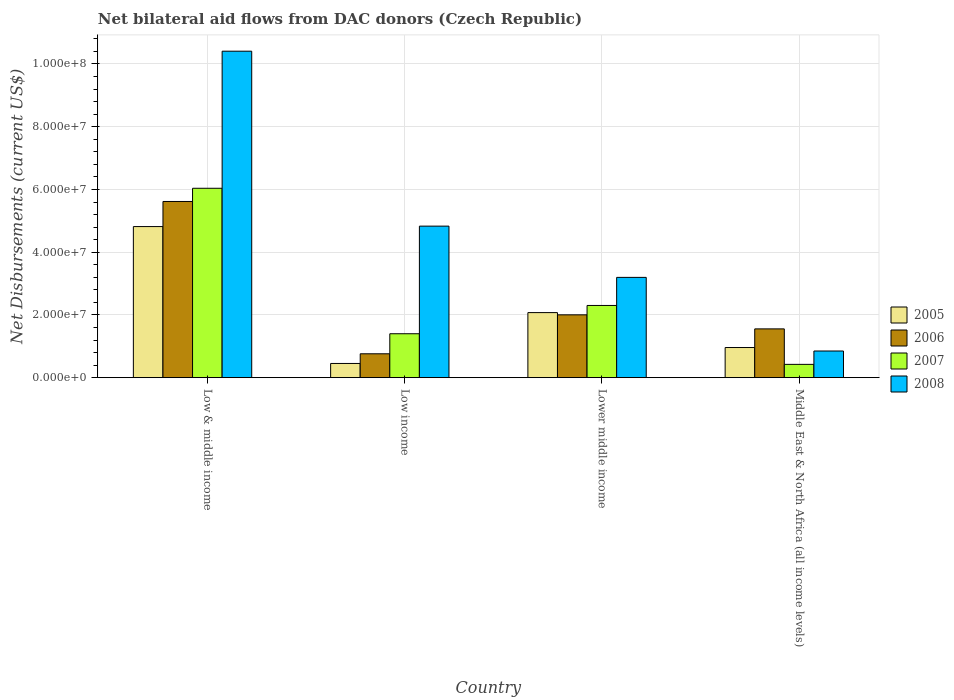How many groups of bars are there?
Offer a terse response. 4. Are the number of bars per tick equal to the number of legend labels?
Keep it short and to the point. Yes. Are the number of bars on each tick of the X-axis equal?
Keep it short and to the point. Yes. How many bars are there on the 1st tick from the left?
Make the answer very short. 4. What is the net bilateral aid flows in 2008 in Middle East & North Africa (all income levels)?
Offer a terse response. 8.50e+06. Across all countries, what is the maximum net bilateral aid flows in 2007?
Provide a short and direct response. 6.04e+07. Across all countries, what is the minimum net bilateral aid flows in 2008?
Keep it short and to the point. 8.50e+06. What is the total net bilateral aid flows in 2008 in the graph?
Provide a short and direct response. 1.93e+08. What is the difference between the net bilateral aid flows in 2008 in Low & middle income and that in Lower middle income?
Your answer should be very brief. 7.21e+07. What is the difference between the net bilateral aid flows in 2008 in Low income and the net bilateral aid flows in 2005 in Middle East & North Africa (all income levels)?
Make the answer very short. 3.87e+07. What is the average net bilateral aid flows in 2007 per country?
Ensure brevity in your answer.  2.54e+07. What is the difference between the net bilateral aid flows of/in 2008 and net bilateral aid flows of/in 2006 in Low income?
Your answer should be compact. 4.07e+07. In how many countries, is the net bilateral aid flows in 2007 greater than 56000000 US$?
Your response must be concise. 1. What is the ratio of the net bilateral aid flows in 2007 in Low income to that in Lower middle income?
Your response must be concise. 0.61. Is the difference between the net bilateral aid flows in 2008 in Lower middle income and Middle East & North Africa (all income levels) greater than the difference between the net bilateral aid flows in 2006 in Lower middle income and Middle East & North Africa (all income levels)?
Ensure brevity in your answer.  Yes. What is the difference between the highest and the second highest net bilateral aid flows in 2007?
Your answer should be very brief. 3.74e+07. What is the difference between the highest and the lowest net bilateral aid flows in 2006?
Your answer should be compact. 4.86e+07. In how many countries, is the net bilateral aid flows in 2005 greater than the average net bilateral aid flows in 2005 taken over all countries?
Your response must be concise. 1. Is the sum of the net bilateral aid flows in 2007 in Low & middle income and Low income greater than the maximum net bilateral aid flows in 2006 across all countries?
Offer a terse response. Yes. What does the 4th bar from the right in Middle East & North Africa (all income levels) represents?
Offer a terse response. 2005. Is it the case that in every country, the sum of the net bilateral aid flows in 2005 and net bilateral aid flows in 2006 is greater than the net bilateral aid flows in 2008?
Make the answer very short. No. How many bars are there?
Make the answer very short. 16. Does the graph contain any zero values?
Make the answer very short. No. Does the graph contain grids?
Your answer should be very brief. Yes. Where does the legend appear in the graph?
Keep it short and to the point. Center right. What is the title of the graph?
Give a very brief answer. Net bilateral aid flows from DAC donors (Czech Republic). What is the label or title of the X-axis?
Give a very brief answer. Country. What is the label or title of the Y-axis?
Keep it short and to the point. Net Disbursements (current US$). What is the Net Disbursements (current US$) in 2005 in Low & middle income?
Make the answer very short. 4.82e+07. What is the Net Disbursements (current US$) in 2006 in Low & middle income?
Keep it short and to the point. 5.62e+07. What is the Net Disbursements (current US$) in 2007 in Low & middle income?
Ensure brevity in your answer.  6.04e+07. What is the Net Disbursements (current US$) in 2008 in Low & middle income?
Give a very brief answer. 1.04e+08. What is the Net Disbursements (current US$) in 2005 in Low income?
Your response must be concise. 4.53e+06. What is the Net Disbursements (current US$) of 2006 in Low income?
Your response must be concise. 7.61e+06. What is the Net Disbursements (current US$) in 2007 in Low income?
Offer a very short reply. 1.40e+07. What is the Net Disbursements (current US$) in 2008 in Low income?
Provide a short and direct response. 4.83e+07. What is the Net Disbursements (current US$) in 2005 in Lower middle income?
Offer a terse response. 2.07e+07. What is the Net Disbursements (current US$) in 2006 in Lower middle income?
Offer a terse response. 2.00e+07. What is the Net Disbursements (current US$) of 2007 in Lower middle income?
Provide a short and direct response. 2.30e+07. What is the Net Disbursements (current US$) in 2008 in Lower middle income?
Your response must be concise. 3.20e+07. What is the Net Disbursements (current US$) in 2005 in Middle East & North Africa (all income levels)?
Offer a terse response. 9.61e+06. What is the Net Disbursements (current US$) of 2006 in Middle East & North Africa (all income levels)?
Keep it short and to the point. 1.56e+07. What is the Net Disbursements (current US$) of 2007 in Middle East & North Africa (all income levels)?
Make the answer very short. 4.24e+06. What is the Net Disbursements (current US$) in 2008 in Middle East & North Africa (all income levels)?
Your answer should be compact. 8.50e+06. Across all countries, what is the maximum Net Disbursements (current US$) in 2005?
Offer a terse response. 4.82e+07. Across all countries, what is the maximum Net Disbursements (current US$) of 2006?
Offer a terse response. 5.62e+07. Across all countries, what is the maximum Net Disbursements (current US$) of 2007?
Keep it short and to the point. 6.04e+07. Across all countries, what is the maximum Net Disbursements (current US$) of 2008?
Ensure brevity in your answer.  1.04e+08. Across all countries, what is the minimum Net Disbursements (current US$) of 2005?
Offer a terse response. 4.53e+06. Across all countries, what is the minimum Net Disbursements (current US$) of 2006?
Offer a very short reply. 7.61e+06. Across all countries, what is the minimum Net Disbursements (current US$) in 2007?
Ensure brevity in your answer.  4.24e+06. Across all countries, what is the minimum Net Disbursements (current US$) of 2008?
Your answer should be compact. 8.50e+06. What is the total Net Disbursements (current US$) in 2005 in the graph?
Offer a very short reply. 8.30e+07. What is the total Net Disbursements (current US$) in 2006 in the graph?
Provide a succinct answer. 9.94e+07. What is the total Net Disbursements (current US$) of 2007 in the graph?
Your response must be concise. 1.02e+08. What is the total Net Disbursements (current US$) in 2008 in the graph?
Offer a very short reply. 1.93e+08. What is the difference between the Net Disbursements (current US$) in 2005 in Low & middle income and that in Low income?
Keep it short and to the point. 4.36e+07. What is the difference between the Net Disbursements (current US$) in 2006 in Low & middle income and that in Low income?
Your answer should be very brief. 4.86e+07. What is the difference between the Net Disbursements (current US$) of 2007 in Low & middle income and that in Low income?
Your answer should be very brief. 4.64e+07. What is the difference between the Net Disbursements (current US$) of 2008 in Low & middle income and that in Low income?
Offer a terse response. 5.58e+07. What is the difference between the Net Disbursements (current US$) of 2005 in Low & middle income and that in Lower middle income?
Make the answer very short. 2.74e+07. What is the difference between the Net Disbursements (current US$) of 2006 in Low & middle income and that in Lower middle income?
Your response must be concise. 3.61e+07. What is the difference between the Net Disbursements (current US$) in 2007 in Low & middle income and that in Lower middle income?
Provide a short and direct response. 3.74e+07. What is the difference between the Net Disbursements (current US$) in 2008 in Low & middle income and that in Lower middle income?
Offer a very short reply. 7.21e+07. What is the difference between the Net Disbursements (current US$) of 2005 in Low & middle income and that in Middle East & North Africa (all income levels)?
Your answer should be compact. 3.86e+07. What is the difference between the Net Disbursements (current US$) in 2006 in Low & middle income and that in Middle East & North Africa (all income levels)?
Offer a terse response. 4.06e+07. What is the difference between the Net Disbursements (current US$) of 2007 in Low & middle income and that in Middle East & North Africa (all income levels)?
Provide a succinct answer. 5.61e+07. What is the difference between the Net Disbursements (current US$) in 2008 in Low & middle income and that in Middle East & North Africa (all income levels)?
Provide a short and direct response. 9.56e+07. What is the difference between the Net Disbursements (current US$) of 2005 in Low income and that in Lower middle income?
Your answer should be very brief. -1.62e+07. What is the difference between the Net Disbursements (current US$) of 2006 in Low income and that in Lower middle income?
Offer a terse response. -1.24e+07. What is the difference between the Net Disbursements (current US$) in 2007 in Low income and that in Lower middle income?
Keep it short and to the point. -9.02e+06. What is the difference between the Net Disbursements (current US$) in 2008 in Low income and that in Lower middle income?
Your answer should be very brief. 1.63e+07. What is the difference between the Net Disbursements (current US$) in 2005 in Low income and that in Middle East & North Africa (all income levels)?
Make the answer very short. -5.08e+06. What is the difference between the Net Disbursements (current US$) of 2006 in Low income and that in Middle East & North Africa (all income levels)?
Your answer should be very brief. -7.94e+06. What is the difference between the Net Disbursements (current US$) of 2007 in Low income and that in Middle East & North Africa (all income levels)?
Your answer should be very brief. 9.76e+06. What is the difference between the Net Disbursements (current US$) in 2008 in Low income and that in Middle East & North Africa (all income levels)?
Offer a terse response. 3.98e+07. What is the difference between the Net Disbursements (current US$) of 2005 in Lower middle income and that in Middle East & North Africa (all income levels)?
Make the answer very short. 1.11e+07. What is the difference between the Net Disbursements (current US$) in 2006 in Lower middle income and that in Middle East & North Africa (all income levels)?
Your answer should be very brief. 4.48e+06. What is the difference between the Net Disbursements (current US$) of 2007 in Lower middle income and that in Middle East & North Africa (all income levels)?
Ensure brevity in your answer.  1.88e+07. What is the difference between the Net Disbursements (current US$) of 2008 in Lower middle income and that in Middle East & North Africa (all income levels)?
Keep it short and to the point. 2.35e+07. What is the difference between the Net Disbursements (current US$) in 2005 in Low & middle income and the Net Disbursements (current US$) in 2006 in Low income?
Make the answer very short. 4.06e+07. What is the difference between the Net Disbursements (current US$) in 2005 in Low & middle income and the Net Disbursements (current US$) in 2007 in Low income?
Make the answer very short. 3.42e+07. What is the difference between the Net Disbursements (current US$) in 2005 in Low & middle income and the Net Disbursements (current US$) in 2008 in Low income?
Your answer should be very brief. -1.40e+05. What is the difference between the Net Disbursements (current US$) in 2006 in Low & middle income and the Net Disbursements (current US$) in 2007 in Low income?
Provide a short and direct response. 4.22e+07. What is the difference between the Net Disbursements (current US$) in 2006 in Low & middle income and the Net Disbursements (current US$) in 2008 in Low income?
Provide a succinct answer. 7.86e+06. What is the difference between the Net Disbursements (current US$) in 2007 in Low & middle income and the Net Disbursements (current US$) in 2008 in Low income?
Make the answer very short. 1.21e+07. What is the difference between the Net Disbursements (current US$) in 2005 in Low & middle income and the Net Disbursements (current US$) in 2006 in Lower middle income?
Make the answer very short. 2.81e+07. What is the difference between the Net Disbursements (current US$) in 2005 in Low & middle income and the Net Disbursements (current US$) in 2007 in Lower middle income?
Ensure brevity in your answer.  2.52e+07. What is the difference between the Net Disbursements (current US$) in 2005 in Low & middle income and the Net Disbursements (current US$) in 2008 in Lower middle income?
Give a very brief answer. 1.62e+07. What is the difference between the Net Disbursements (current US$) in 2006 in Low & middle income and the Net Disbursements (current US$) in 2007 in Lower middle income?
Ensure brevity in your answer.  3.32e+07. What is the difference between the Net Disbursements (current US$) in 2006 in Low & middle income and the Net Disbursements (current US$) in 2008 in Lower middle income?
Keep it short and to the point. 2.42e+07. What is the difference between the Net Disbursements (current US$) of 2007 in Low & middle income and the Net Disbursements (current US$) of 2008 in Lower middle income?
Ensure brevity in your answer.  2.84e+07. What is the difference between the Net Disbursements (current US$) in 2005 in Low & middle income and the Net Disbursements (current US$) in 2006 in Middle East & North Africa (all income levels)?
Make the answer very short. 3.26e+07. What is the difference between the Net Disbursements (current US$) of 2005 in Low & middle income and the Net Disbursements (current US$) of 2007 in Middle East & North Africa (all income levels)?
Provide a succinct answer. 4.39e+07. What is the difference between the Net Disbursements (current US$) of 2005 in Low & middle income and the Net Disbursements (current US$) of 2008 in Middle East & North Africa (all income levels)?
Offer a terse response. 3.97e+07. What is the difference between the Net Disbursements (current US$) of 2006 in Low & middle income and the Net Disbursements (current US$) of 2007 in Middle East & North Africa (all income levels)?
Provide a succinct answer. 5.19e+07. What is the difference between the Net Disbursements (current US$) in 2006 in Low & middle income and the Net Disbursements (current US$) in 2008 in Middle East & North Africa (all income levels)?
Offer a terse response. 4.77e+07. What is the difference between the Net Disbursements (current US$) of 2007 in Low & middle income and the Net Disbursements (current US$) of 2008 in Middle East & North Africa (all income levels)?
Provide a short and direct response. 5.19e+07. What is the difference between the Net Disbursements (current US$) in 2005 in Low income and the Net Disbursements (current US$) in 2006 in Lower middle income?
Offer a terse response. -1.55e+07. What is the difference between the Net Disbursements (current US$) in 2005 in Low income and the Net Disbursements (current US$) in 2007 in Lower middle income?
Provide a succinct answer. -1.85e+07. What is the difference between the Net Disbursements (current US$) in 2005 in Low income and the Net Disbursements (current US$) in 2008 in Lower middle income?
Give a very brief answer. -2.74e+07. What is the difference between the Net Disbursements (current US$) of 2006 in Low income and the Net Disbursements (current US$) of 2007 in Lower middle income?
Offer a very short reply. -1.54e+07. What is the difference between the Net Disbursements (current US$) of 2006 in Low income and the Net Disbursements (current US$) of 2008 in Lower middle income?
Ensure brevity in your answer.  -2.44e+07. What is the difference between the Net Disbursements (current US$) in 2007 in Low income and the Net Disbursements (current US$) in 2008 in Lower middle income?
Your answer should be very brief. -1.80e+07. What is the difference between the Net Disbursements (current US$) in 2005 in Low income and the Net Disbursements (current US$) in 2006 in Middle East & North Africa (all income levels)?
Provide a succinct answer. -1.10e+07. What is the difference between the Net Disbursements (current US$) in 2005 in Low income and the Net Disbursements (current US$) in 2007 in Middle East & North Africa (all income levels)?
Your response must be concise. 2.90e+05. What is the difference between the Net Disbursements (current US$) of 2005 in Low income and the Net Disbursements (current US$) of 2008 in Middle East & North Africa (all income levels)?
Offer a very short reply. -3.97e+06. What is the difference between the Net Disbursements (current US$) in 2006 in Low income and the Net Disbursements (current US$) in 2007 in Middle East & North Africa (all income levels)?
Provide a short and direct response. 3.37e+06. What is the difference between the Net Disbursements (current US$) of 2006 in Low income and the Net Disbursements (current US$) of 2008 in Middle East & North Africa (all income levels)?
Your answer should be compact. -8.90e+05. What is the difference between the Net Disbursements (current US$) in 2007 in Low income and the Net Disbursements (current US$) in 2008 in Middle East & North Africa (all income levels)?
Offer a terse response. 5.50e+06. What is the difference between the Net Disbursements (current US$) in 2005 in Lower middle income and the Net Disbursements (current US$) in 2006 in Middle East & North Africa (all income levels)?
Your answer should be compact. 5.19e+06. What is the difference between the Net Disbursements (current US$) in 2005 in Lower middle income and the Net Disbursements (current US$) in 2007 in Middle East & North Africa (all income levels)?
Your answer should be very brief. 1.65e+07. What is the difference between the Net Disbursements (current US$) in 2005 in Lower middle income and the Net Disbursements (current US$) in 2008 in Middle East & North Africa (all income levels)?
Offer a very short reply. 1.22e+07. What is the difference between the Net Disbursements (current US$) of 2006 in Lower middle income and the Net Disbursements (current US$) of 2007 in Middle East & North Africa (all income levels)?
Offer a terse response. 1.58e+07. What is the difference between the Net Disbursements (current US$) in 2006 in Lower middle income and the Net Disbursements (current US$) in 2008 in Middle East & North Africa (all income levels)?
Provide a short and direct response. 1.15e+07. What is the difference between the Net Disbursements (current US$) of 2007 in Lower middle income and the Net Disbursements (current US$) of 2008 in Middle East & North Africa (all income levels)?
Offer a very short reply. 1.45e+07. What is the average Net Disbursements (current US$) of 2005 per country?
Give a very brief answer. 2.08e+07. What is the average Net Disbursements (current US$) of 2006 per country?
Your answer should be very brief. 2.48e+07. What is the average Net Disbursements (current US$) of 2007 per country?
Give a very brief answer. 2.54e+07. What is the average Net Disbursements (current US$) of 2008 per country?
Give a very brief answer. 4.82e+07. What is the difference between the Net Disbursements (current US$) in 2005 and Net Disbursements (current US$) in 2006 in Low & middle income?
Give a very brief answer. -8.00e+06. What is the difference between the Net Disbursements (current US$) in 2005 and Net Disbursements (current US$) in 2007 in Low & middle income?
Give a very brief answer. -1.22e+07. What is the difference between the Net Disbursements (current US$) of 2005 and Net Disbursements (current US$) of 2008 in Low & middle income?
Provide a succinct answer. -5.59e+07. What is the difference between the Net Disbursements (current US$) of 2006 and Net Disbursements (current US$) of 2007 in Low & middle income?
Give a very brief answer. -4.21e+06. What is the difference between the Net Disbursements (current US$) in 2006 and Net Disbursements (current US$) in 2008 in Low & middle income?
Provide a succinct answer. -4.79e+07. What is the difference between the Net Disbursements (current US$) of 2007 and Net Disbursements (current US$) of 2008 in Low & middle income?
Offer a terse response. -4.37e+07. What is the difference between the Net Disbursements (current US$) in 2005 and Net Disbursements (current US$) in 2006 in Low income?
Offer a very short reply. -3.08e+06. What is the difference between the Net Disbursements (current US$) in 2005 and Net Disbursements (current US$) in 2007 in Low income?
Your answer should be compact. -9.47e+06. What is the difference between the Net Disbursements (current US$) in 2005 and Net Disbursements (current US$) in 2008 in Low income?
Offer a very short reply. -4.38e+07. What is the difference between the Net Disbursements (current US$) of 2006 and Net Disbursements (current US$) of 2007 in Low income?
Offer a very short reply. -6.39e+06. What is the difference between the Net Disbursements (current US$) in 2006 and Net Disbursements (current US$) in 2008 in Low income?
Your answer should be very brief. -4.07e+07. What is the difference between the Net Disbursements (current US$) in 2007 and Net Disbursements (current US$) in 2008 in Low income?
Make the answer very short. -3.43e+07. What is the difference between the Net Disbursements (current US$) in 2005 and Net Disbursements (current US$) in 2006 in Lower middle income?
Keep it short and to the point. 7.10e+05. What is the difference between the Net Disbursements (current US$) of 2005 and Net Disbursements (current US$) of 2007 in Lower middle income?
Offer a very short reply. -2.28e+06. What is the difference between the Net Disbursements (current US$) of 2005 and Net Disbursements (current US$) of 2008 in Lower middle income?
Ensure brevity in your answer.  -1.12e+07. What is the difference between the Net Disbursements (current US$) of 2006 and Net Disbursements (current US$) of 2007 in Lower middle income?
Provide a succinct answer. -2.99e+06. What is the difference between the Net Disbursements (current US$) in 2006 and Net Disbursements (current US$) in 2008 in Lower middle income?
Provide a short and direct response. -1.19e+07. What is the difference between the Net Disbursements (current US$) of 2007 and Net Disbursements (current US$) of 2008 in Lower middle income?
Your answer should be compact. -8.95e+06. What is the difference between the Net Disbursements (current US$) of 2005 and Net Disbursements (current US$) of 2006 in Middle East & North Africa (all income levels)?
Give a very brief answer. -5.94e+06. What is the difference between the Net Disbursements (current US$) of 2005 and Net Disbursements (current US$) of 2007 in Middle East & North Africa (all income levels)?
Keep it short and to the point. 5.37e+06. What is the difference between the Net Disbursements (current US$) of 2005 and Net Disbursements (current US$) of 2008 in Middle East & North Africa (all income levels)?
Ensure brevity in your answer.  1.11e+06. What is the difference between the Net Disbursements (current US$) in 2006 and Net Disbursements (current US$) in 2007 in Middle East & North Africa (all income levels)?
Ensure brevity in your answer.  1.13e+07. What is the difference between the Net Disbursements (current US$) in 2006 and Net Disbursements (current US$) in 2008 in Middle East & North Africa (all income levels)?
Your answer should be very brief. 7.05e+06. What is the difference between the Net Disbursements (current US$) of 2007 and Net Disbursements (current US$) of 2008 in Middle East & North Africa (all income levels)?
Your answer should be compact. -4.26e+06. What is the ratio of the Net Disbursements (current US$) of 2005 in Low & middle income to that in Low income?
Your answer should be compact. 10.63. What is the ratio of the Net Disbursements (current US$) in 2006 in Low & middle income to that in Low income?
Provide a succinct answer. 7.38. What is the ratio of the Net Disbursements (current US$) in 2007 in Low & middle income to that in Low income?
Ensure brevity in your answer.  4.31. What is the ratio of the Net Disbursements (current US$) of 2008 in Low & middle income to that in Low income?
Ensure brevity in your answer.  2.15. What is the ratio of the Net Disbursements (current US$) of 2005 in Low & middle income to that in Lower middle income?
Keep it short and to the point. 2.32. What is the ratio of the Net Disbursements (current US$) of 2006 in Low & middle income to that in Lower middle income?
Provide a short and direct response. 2.8. What is the ratio of the Net Disbursements (current US$) of 2007 in Low & middle income to that in Lower middle income?
Provide a succinct answer. 2.62. What is the ratio of the Net Disbursements (current US$) of 2008 in Low & middle income to that in Lower middle income?
Offer a terse response. 3.26. What is the ratio of the Net Disbursements (current US$) of 2005 in Low & middle income to that in Middle East & North Africa (all income levels)?
Your answer should be very brief. 5.01. What is the ratio of the Net Disbursements (current US$) of 2006 in Low & middle income to that in Middle East & North Africa (all income levels)?
Ensure brevity in your answer.  3.61. What is the ratio of the Net Disbursements (current US$) of 2007 in Low & middle income to that in Middle East & North Africa (all income levels)?
Your answer should be very brief. 14.24. What is the ratio of the Net Disbursements (current US$) of 2008 in Low & middle income to that in Middle East & North Africa (all income levels)?
Provide a short and direct response. 12.24. What is the ratio of the Net Disbursements (current US$) in 2005 in Low income to that in Lower middle income?
Ensure brevity in your answer.  0.22. What is the ratio of the Net Disbursements (current US$) in 2006 in Low income to that in Lower middle income?
Make the answer very short. 0.38. What is the ratio of the Net Disbursements (current US$) in 2007 in Low income to that in Lower middle income?
Ensure brevity in your answer.  0.61. What is the ratio of the Net Disbursements (current US$) in 2008 in Low income to that in Lower middle income?
Offer a very short reply. 1.51. What is the ratio of the Net Disbursements (current US$) in 2005 in Low income to that in Middle East & North Africa (all income levels)?
Offer a very short reply. 0.47. What is the ratio of the Net Disbursements (current US$) of 2006 in Low income to that in Middle East & North Africa (all income levels)?
Make the answer very short. 0.49. What is the ratio of the Net Disbursements (current US$) in 2007 in Low income to that in Middle East & North Africa (all income levels)?
Provide a short and direct response. 3.3. What is the ratio of the Net Disbursements (current US$) in 2008 in Low income to that in Middle East & North Africa (all income levels)?
Give a very brief answer. 5.68. What is the ratio of the Net Disbursements (current US$) in 2005 in Lower middle income to that in Middle East & North Africa (all income levels)?
Give a very brief answer. 2.16. What is the ratio of the Net Disbursements (current US$) of 2006 in Lower middle income to that in Middle East & North Africa (all income levels)?
Your answer should be compact. 1.29. What is the ratio of the Net Disbursements (current US$) in 2007 in Lower middle income to that in Middle East & North Africa (all income levels)?
Ensure brevity in your answer.  5.43. What is the ratio of the Net Disbursements (current US$) in 2008 in Lower middle income to that in Middle East & North Africa (all income levels)?
Keep it short and to the point. 3.76. What is the difference between the highest and the second highest Net Disbursements (current US$) of 2005?
Give a very brief answer. 2.74e+07. What is the difference between the highest and the second highest Net Disbursements (current US$) in 2006?
Your answer should be very brief. 3.61e+07. What is the difference between the highest and the second highest Net Disbursements (current US$) in 2007?
Give a very brief answer. 3.74e+07. What is the difference between the highest and the second highest Net Disbursements (current US$) of 2008?
Make the answer very short. 5.58e+07. What is the difference between the highest and the lowest Net Disbursements (current US$) in 2005?
Offer a very short reply. 4.36e+07. What is the difference between the highest and the lowest Net Disbursements (current US$) in 2006?
Make the answer very short. 4.86e+07. What is the difference between the highest and the lowest Net Disbursements (current US$) of 2007?
Keep it short and to the point. 5.61e+07. What is the difference between the highest and the lowest Net Disbursements (current US$) of 2008?
Give a very brief answer. 9.56e+07. 